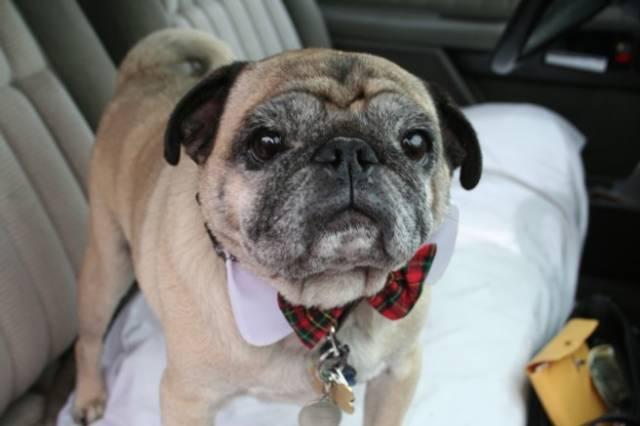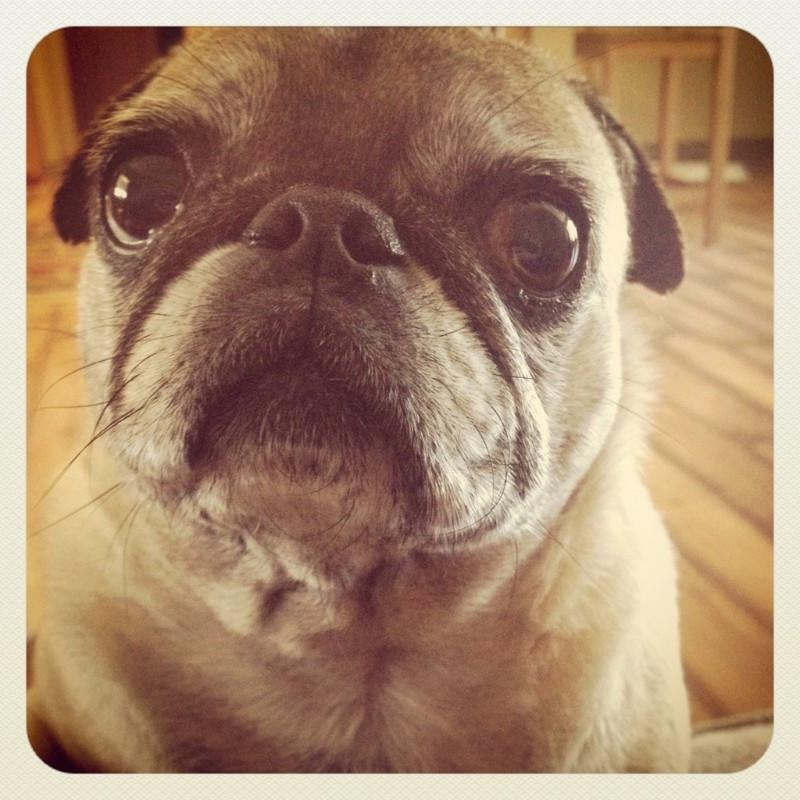The first image is the image on the left, the second image is the image on the right. Analyze the images presented: Is the assertion "A pug with a dark muzzle is sleeping on a blanket and in contact with something beige and plush in the left image." valid? Answer yes or no. No. The first image is the image on the left, the second image is the image on the right. Given the left and right images, does the statement "There is at least one pug wearing a collar with red in it." hold true? Answer yes or no. Yes. 